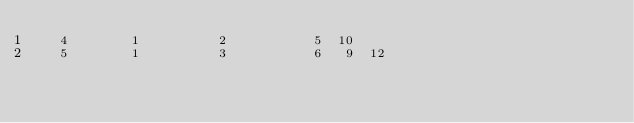Convert code to text. <code><loc_0><loc_0><loc_500><loc_500><_ObjectiveC_>   4        1          2           5  10
   5        1          3           6   9  12</code> 